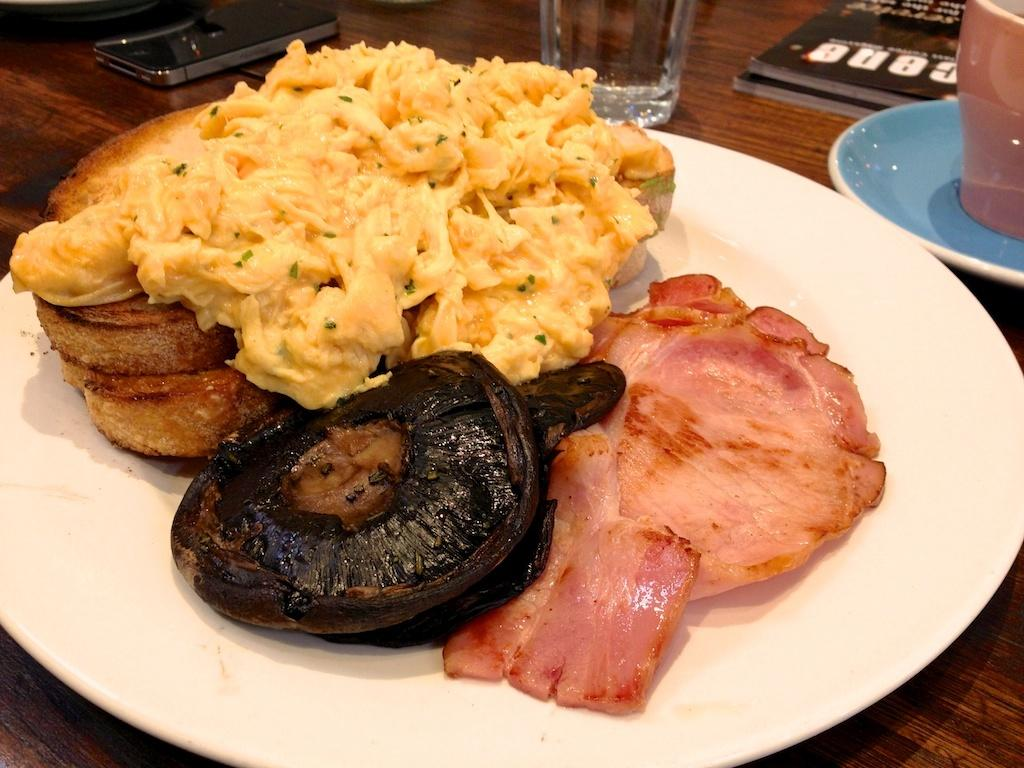What is the color of the plate that holds the food item in the image? The plate is white in color. Where is the plate placed in the image? The plate is placed on a wooden table top. What is the other beverage container present in the image? There is a water glass beside the plate. What is the color of the teacup beside the plate? The teacup is blue in color. How does the coastline appear in the image? There is no coastline present in the image; it features a food item on a plate, a water glass, and a blue teacup on a wooden table top. 